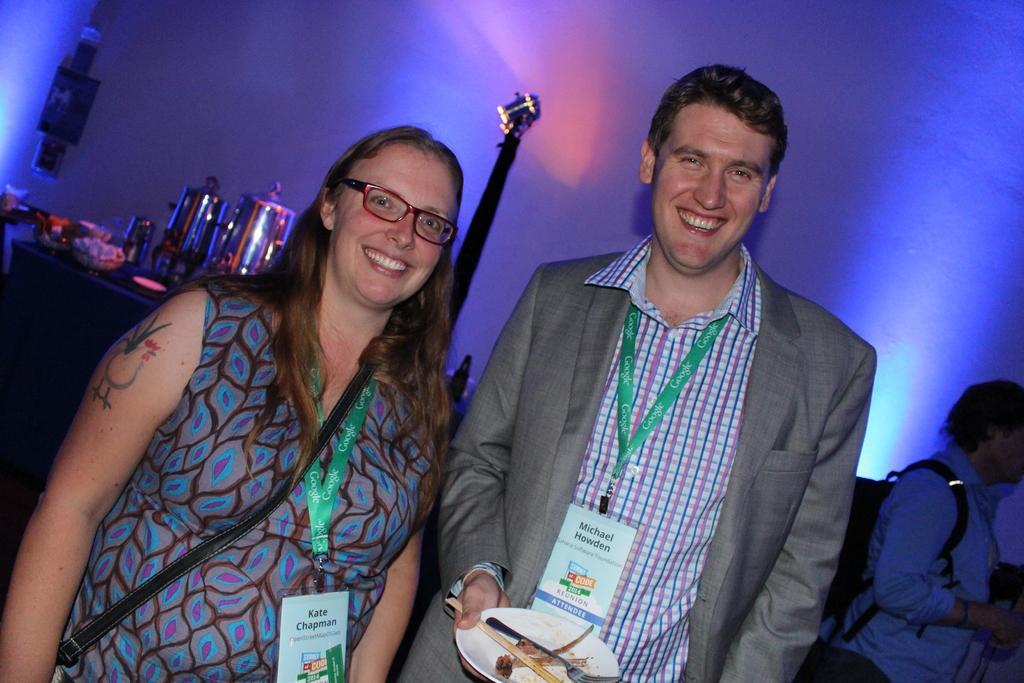Please provide a concise description of this image. There are two people standing and smiling and wire tags, she is carrying a bag and he is holding a plate with fork and food. In the background we can see people and few objects. 